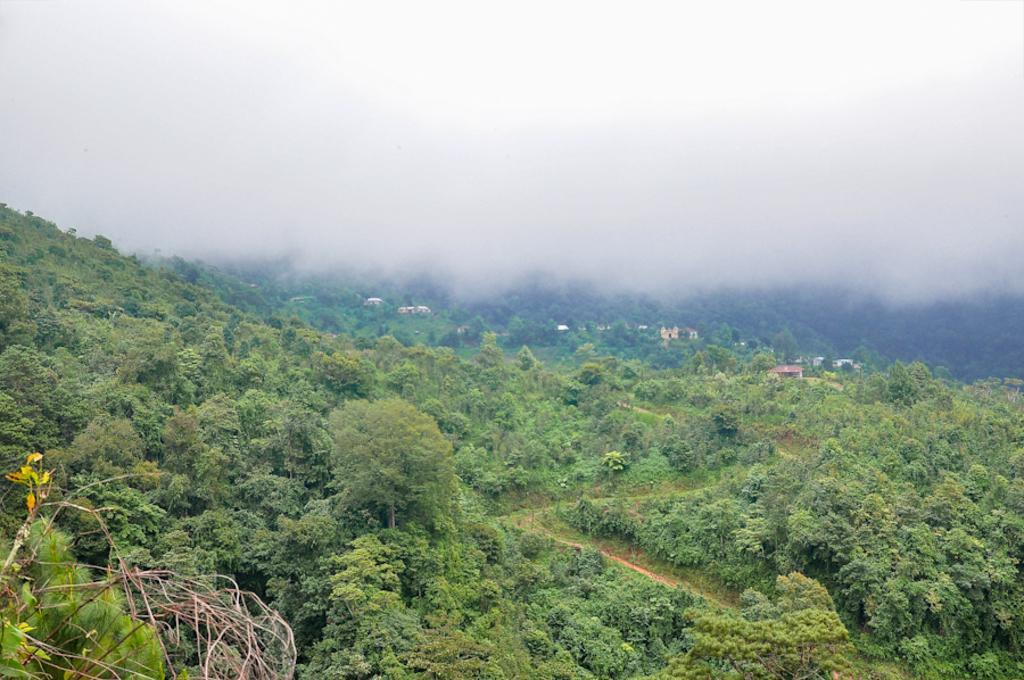Please provide a concise description of this image. In the center of the image there are trees. In the background of the image there is fog there are buildings. 